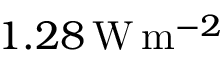Convert formula to latex. <formula><loc_0><loc_0><loc_500><loc_500>1 . 2 8 \, W \, m ^ { - 2 }</formula> 